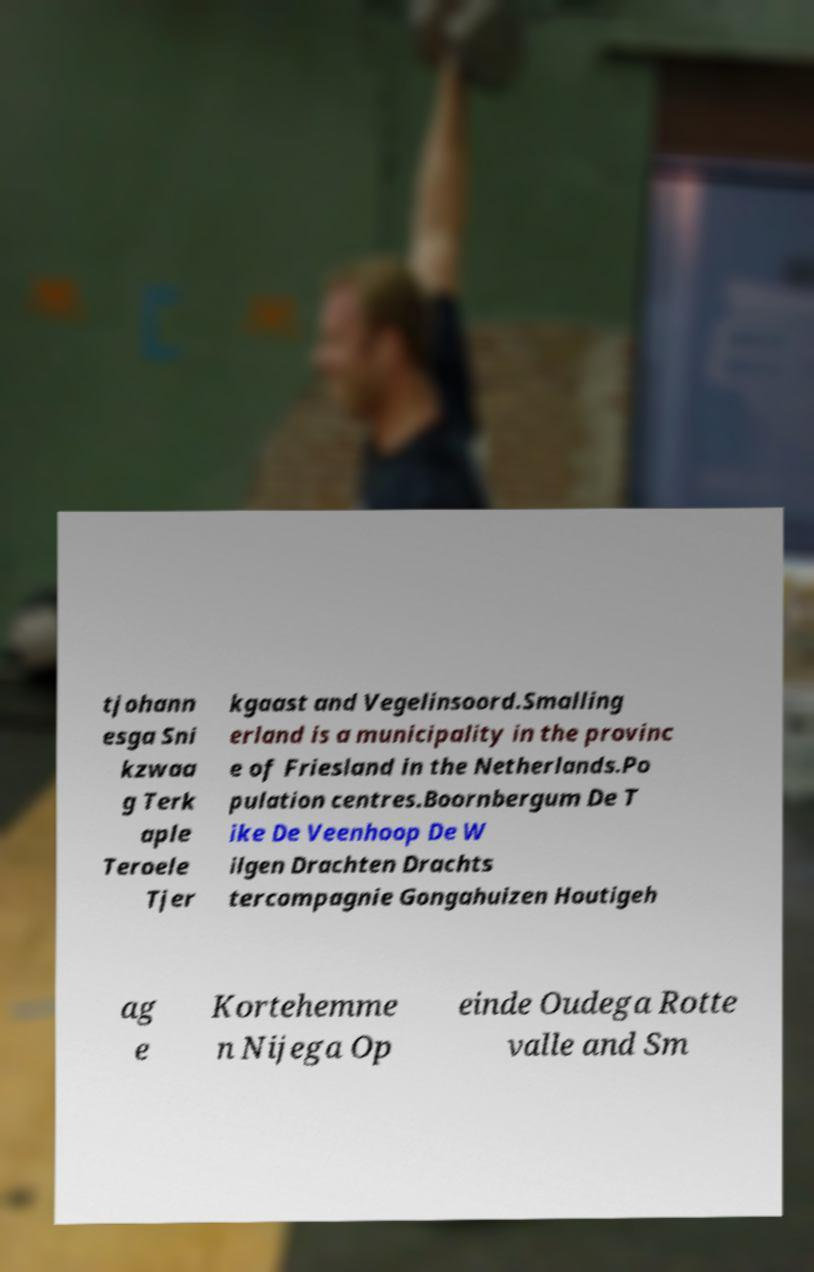For documentation purposes, I need the text within this image transcribed. Could you provide that? tjohann esga Sni kzwaa g Terk aple Teroele Tjer kgaast and Vegelinsoord.Smalling erland is a municipality in the provinc e of Friesland in the Netherlands.Po pulation centres.Boornbergum De T ike De Veenhoop De W ilgen Drachten Drachts tercompagnie Gongahuizen Houtigeh ag e Kortehemme n Nijega Op einde Oudega Rotte valle and Sm 